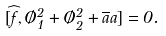Convert formula to latex. <formula><loc_0><loc_0><loc_500><loc_500>[ \widehat { f } , \chi _ { 1 } ^ { 2 } + \chi _ { 2 } ^ { 2 } + \overline { a } a ] = 0 .</formula> 